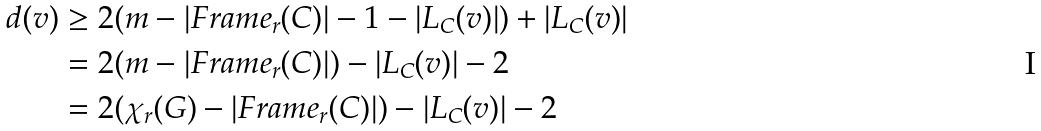Convert formula to latex. <formula><loc_0><loc_0><loc_500><loc_500>d ( v ) & \geq 2 ( m - | F r a m e _ { r } ( C ) | - 1 - | L _ { C } ( v ) | ) + | L _ { C } ( v ) | \\ & = 2 ( m - | F r a m e _ { r } ( C ) | ) - | L _ { C } ( v ) | - 2 \\ & = 2 ( \chi _ { r } ( G ) - | F r a m e _ { r } ( C ) | ) - | L _ { C } ( v ) | - 2</formula> 